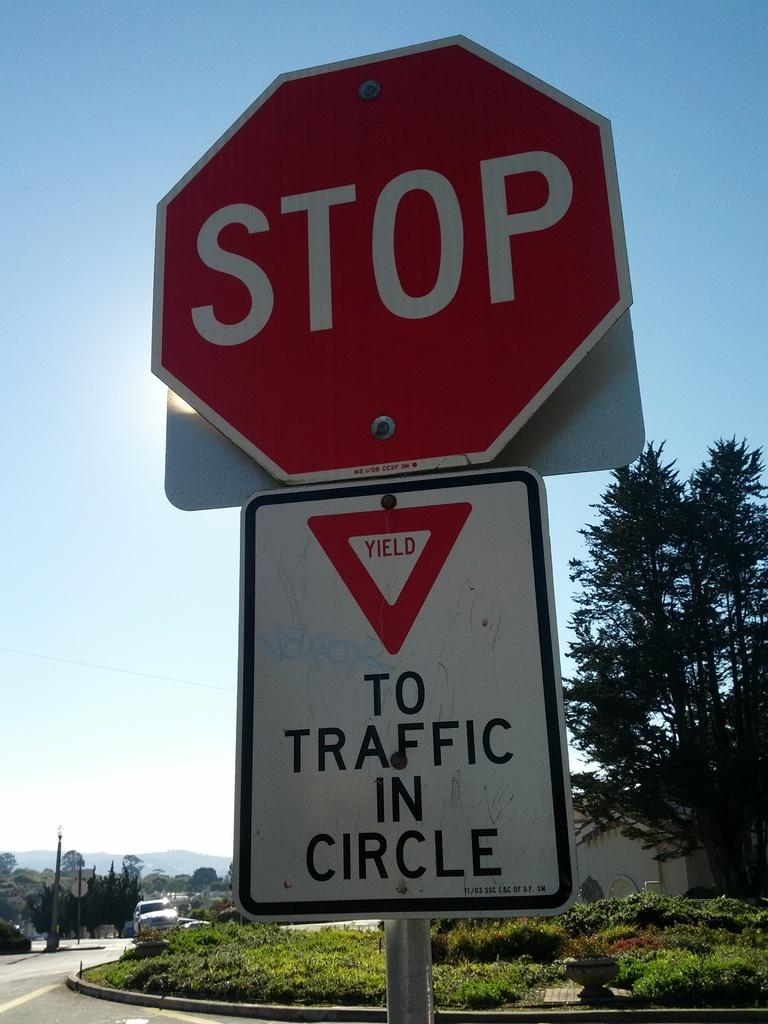<image>
Present a compact description of the photo's key features. A red stop sign that says STOP on it. 